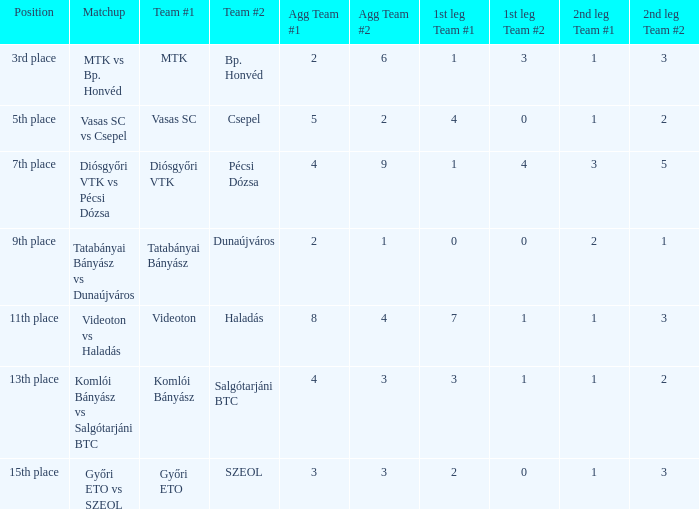What is the 1st leg with a 4-3 agg.? 3-1. Would you mind parsing the complete table? {'header': ['Position', 'Matchup', 'Team #1', 'Team #2', 'Agg Team #1', 'Agg Team #2', '1st leg Team #1', '1st leg Team #2', '2nd leg Team #1', '2nd leg Team #2'], 'rows': [['3rd place', 'MTK vs Bp. Honvéd', 'MTK', 'Bp. Honvéd', '2', '6', '1', '3', '1', '3'], ['5th place', 'Vasas SC vs Csepel', 'Vasas SC', 'Csepel', '5', '2', '4', '0', '1', '2'], ['7th place', 'Diósgyőri VTK vs Pécsi Dózsa', 'Diósgyőri VTK', 'Pécsi Dózsa', '4', '9', '1', '4', '3', '5'], ['9th place', 'Tatabányai Bányász vs Dunaújváros', 'Tatabányai Bányász', 'Dunaújváros', '2', '1', '0', '0', '2', '1'], ['11th place', 'Videoton vs Haladás', 'Videoton', 'Haladás', '8', '4', '7', '1', '1', '3'], ['13th place', 'Komlói Bányász vs Salgótarjáni BTC', 'Komlói Bányász', 'Salgótarjáni BTC', '4', '3', '3', '1', '1', '2'], ['15th place', 'Győri ETO vs SZEOL', 'Győri ETO', 'SZEOL', '3', '3', '2', '0', '1', '3']]} 